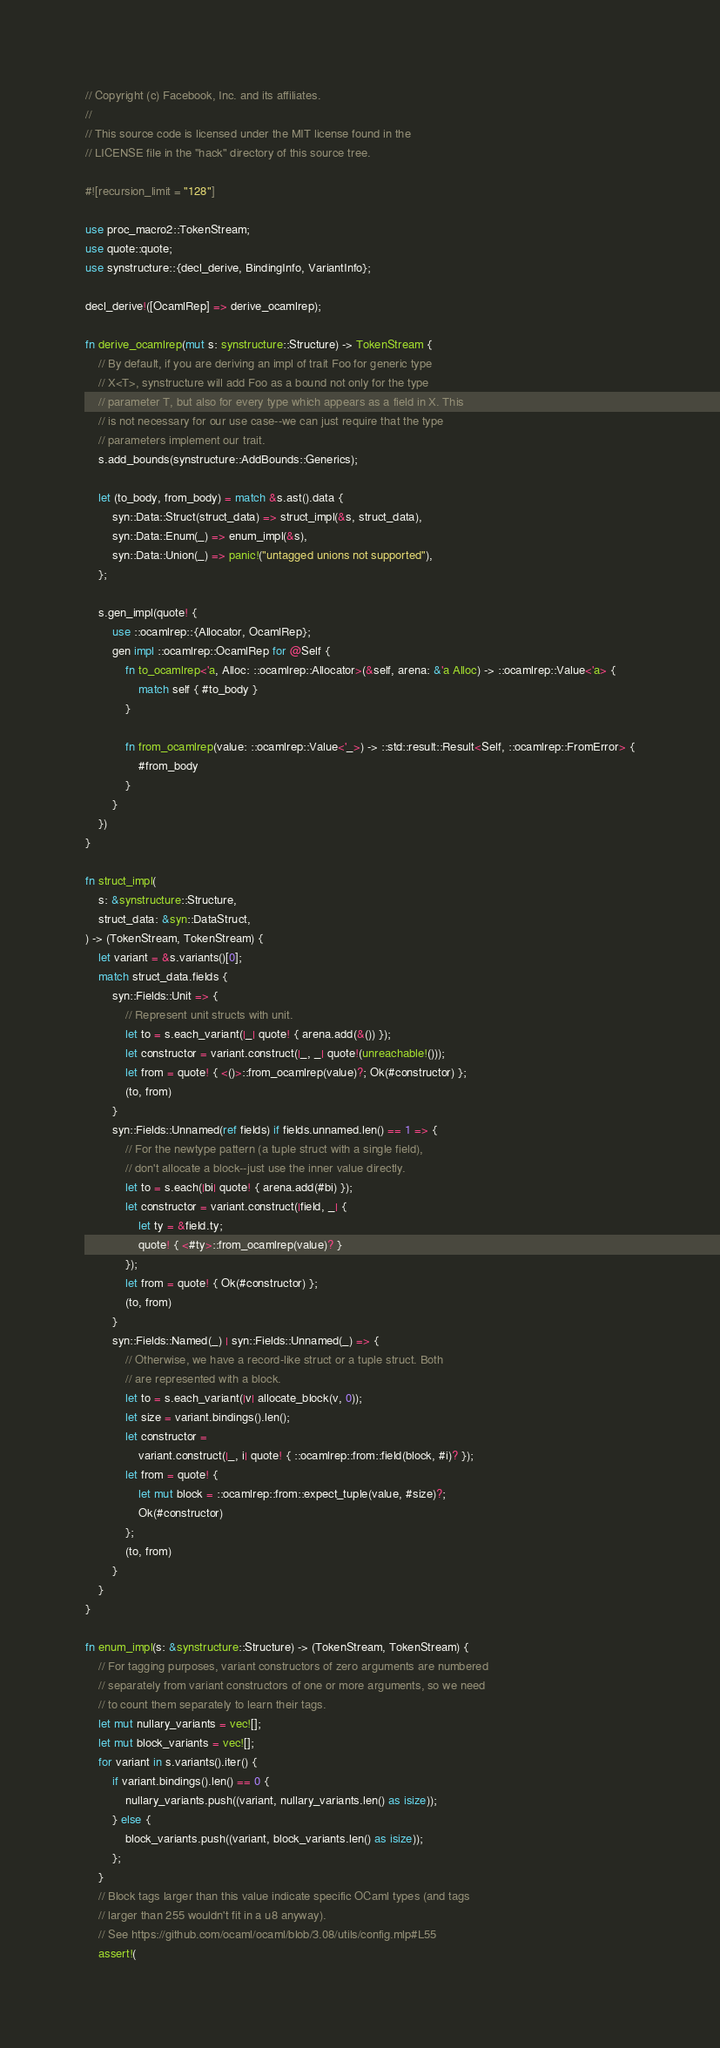Convert code to text. <code><loc_0><loc_0><loc_500><loc_500><_Rust_>// Copyright (c) Facebook, Inc. and its affiliates.
//
// This source code is licensed under the MIT license found in the
// LICENSE file in the "hack" directory of this source tree.

#![recursion_limit = "128"]

use proc_macro2::TokenStream;
use quote::quote;
use synstructure::{decl_derive, BindingInfo, VariantInfo};

decl_derive!([OcamlRep] => derive_ocamlrep);

fn derive_ocamlrep(mut s: synstructure::Structure) -> TokenStream {
    // By default, if you are deriving an impl of trait Foo for generic type
    // X<T>, synstructure will add Foo as a bound not only for the type
    // parameter T, but also for every type which appears as a field in X. This
    // is not necessary for our use case--we can just require that the type
    // parameters implement our trait.
    s.add_bounds(synstructure::AddBounds::Generics);

    let (to_body, from_body) = match &s.ast().data {
        syn::Data::Struct(struct_data) => struct_impl(&s, struct_data),
        syn::Data::Enum(_) => enum_impl(&s),
        syn::Data::Union(_) => panic!("untagged unions not supported"),
    };

    s.gen_impl(quote! {
        use ::ocamlrep::{Allocator, OcamlRep};
        gen impl ::ocamlrep::OcamlRep for @Self {
            fn to_ocamlrep<'a, Alloc: ::ocamlrep::Allocator>(&self, arena: &'a Alloc) -> ::ocamlrep::Value<'a> {
                match self { #to_body }
            }

            fn from_ocamlrep(value: ::ocamlrep::Value<'_>) -> ::std::result::Result<Self, ::ocamlrep::FromError> {
                #from_body
            }
        }
    })
}

fn struct_impl(
    s: &synstructure::Structure,
    struct_data: &syn::DataStruct,
) -> (TokenStream, TokenStream) {
    let variant = &s.variants()[0];
    match struct_data.fields {
        syn::Fields::Unit => {
            // Represent unit structs with unit.
            let to = s.each_variant(|_| quote! { arena.add(&()) });
            let constructor = variant.construct(|_, _| quote!(unreachable!()));
            let from = quote! { <()>::from_ocamlrep(value)?; Ok(#constructor) };
            (to, from)
        }
        syn::Fields::Unnamed(ref fields) if fields.unnamed.len() == 1 => {
            // For the newtype pattern (a tuple struct with a single field),
            // don't allocate a block--just use the inner value directly.
            let to = s.each(|bi| quote! { arena.add(#bi) });
            let constructor = variant.construct(|field, _| {
                let ty = &field.ty;
                quote! { <#ty>::from_ocamlrep(value)? }
            });
            let from = quote! { Ok(#constructor) };
            (to, from)
        }
        syn::Fields::Named(_) | syn::Fields::Unnamed(_) => {
            // Otherwise, we have a record-like struct or a tuple struct. Both
            // are represented with a block.
            let to = s.each_variant(|v| allocate_block(v, 0));
            let size = variant.bindings().len();
            let constructor =
                variant.construct(|_, i| quote! { ::ocamlrep::from::field(block, #i)? });
            let from = quote! {
                let mut block = ::ocamlrep::from::expect_tuple(value, #size)?;
                Ok(#constructor)
            };
            (to, from)
        }
    }
}

fn enum_impl(s: &synstructure::Structure) -> (TokenStream, TokenStream) {
    // For tagging purposes, variant constructors of zero arguments are numbered
    // separately from variant constructors of one or more arguments, so we need
    // to count them separately to learn their tags.
    let mut nullary_variants = vec![];
    let mut block_variants = vec![];
    for variant in s.variants().iter() {
        if variant.bindings().len() == 0 {
            nullary_variants.push((variant, nullary_variants.len() as isize));
        } else {
            block_variants.push((variant, block_variants.len() as isize));
        };
    }
    // Block tags larger than this value indicate specific OCaml types (and tags
    // larger than 255 wouldn't fit in a u8 anyway).
    // See https://github.com/ocaml/ocaml/blob/3.08/utils/config.mlp#L55
    assert!(</code> 